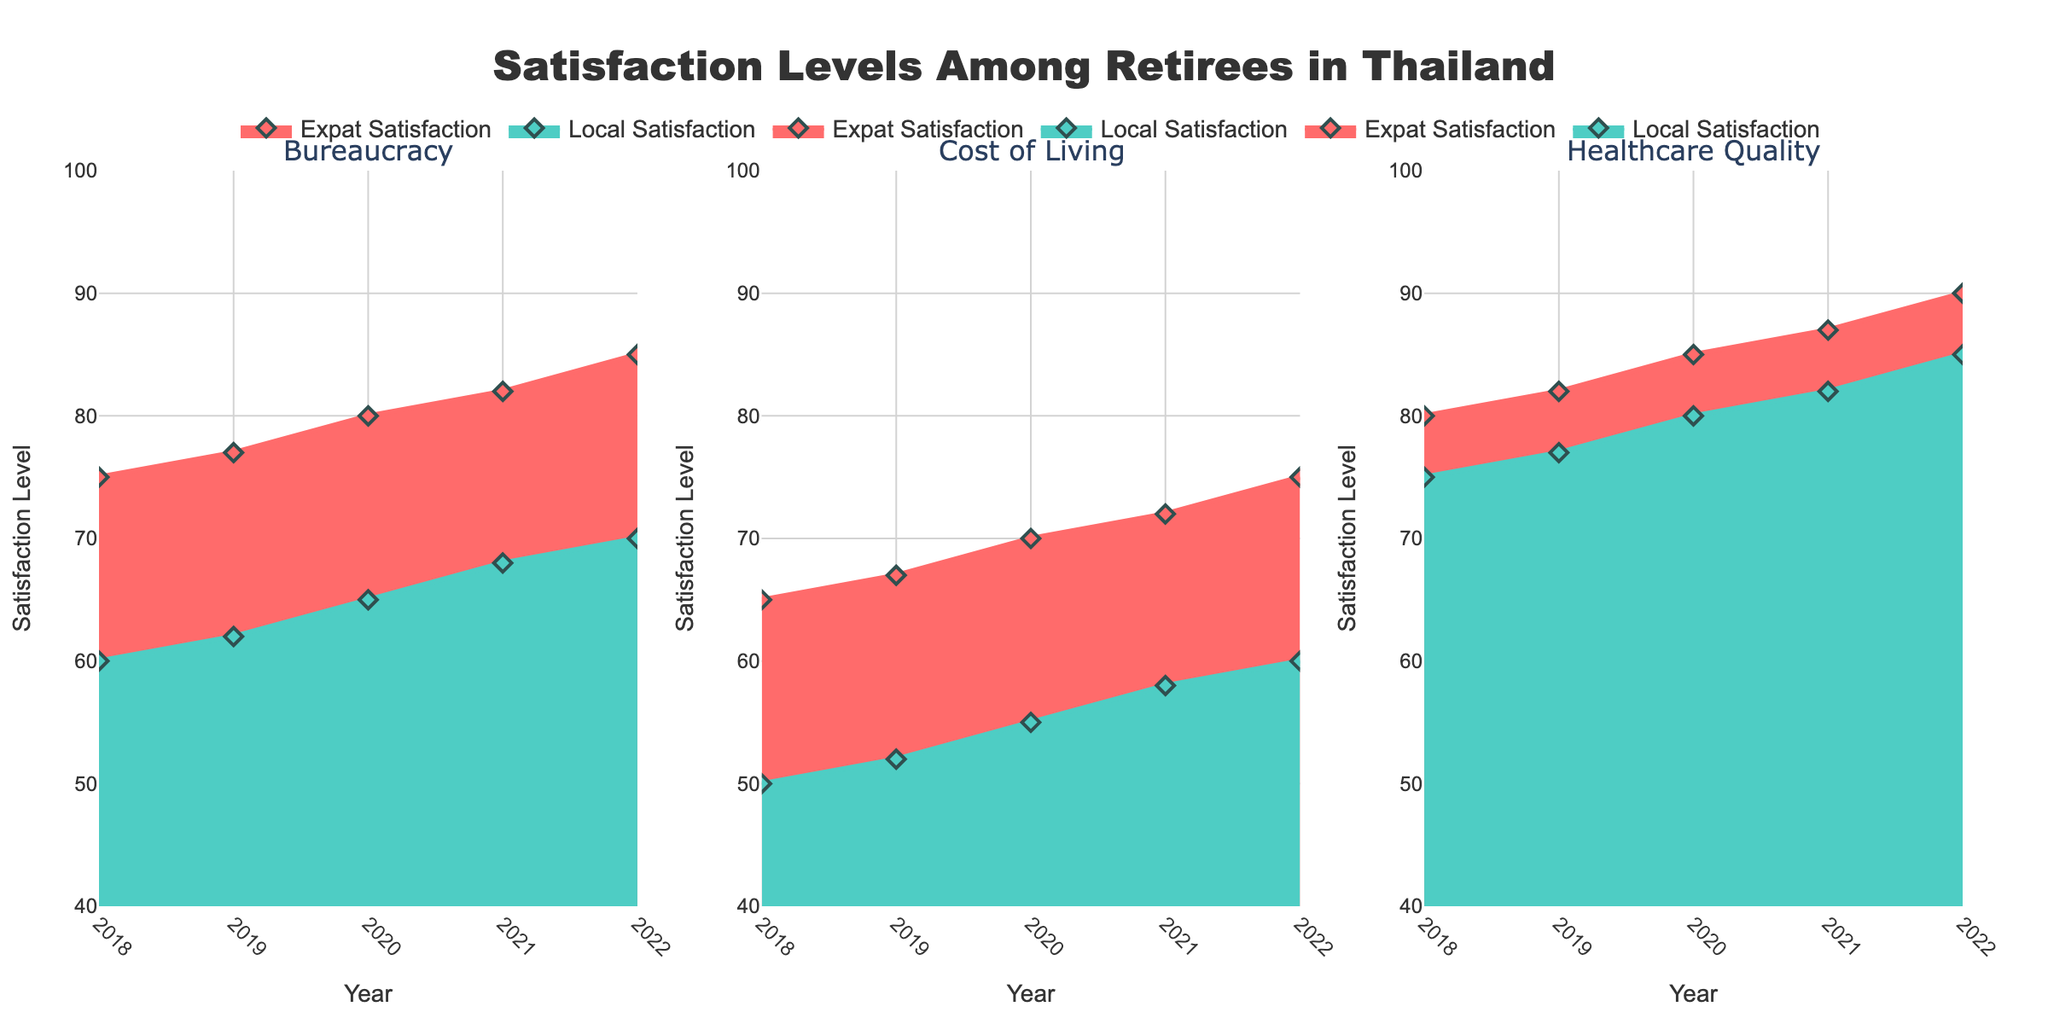What is the title of the figure? The title is located at the top of the figure and reads "Satisfaction Levels Among Retirees in Thailand".
Answer: Satisfaction Levels Among Retirees in Thailand Which factor consistently shows the highest satisfaction levels for both Expat and Local retirees? By examining the three subplots, "Healthcare Quality" consistently has the highest satisfaction levels for both categories.
Answer: Healthcare Quality What was the satisfaction level of Expats with "Bureaucracy" in 2020? Locate the "Bureaucracy" subplot, find the data point for the Expat category in 2020.
Answer: 80 How did the satisfaction levels of Locals with "Cost of Living" change from 2019 to 2021? In the "Cost of Living" subplot, find the values for Locals in 2019 (52) and 2021 (58). Subtract the 2019 value from the 2021 value (58 - 52).
Answer: Increased by 6 points In 2022, which group had a higher satisfaction level regarding "Healthcare Quality"? Compare the 2022 data points in the "Healthcare Quality" subplot for Expats (90) and Locals (85).
Answer: Expats What is the average satisfaction level of Expats in "Cost of Living" from 2018 to 2022? Locate all the data points for Expats in "Cost of Living" subplot (2018: 65, 2019: 67, 2020: 70, 2021: 72, 2022: 75). Sum these values and divide by the number of points (65 + 67 + 70 + 72 + 75) / 5.
Answer: 69.8 Did the satisfaction level with "Bureaucracy" for Locals ever surpass that for Expats during the period shown? Analyze the "Bureaucracy" subplot for overlap where Local satisfaction surpasses Expat satisfaction, which it does not.
Answer: No Which year saw the largest increase in satisfaction for Expats in "Healthcare Quality"? Examine the "Healthcare Quality" subplot for Expats and determine year-to-year changes: 2018 to 2019 (80 to 82: +2), 2019 to 2020 (82 to 85: +3), 2020 to 2021 (85 to 87: +2), 2021 to 2022 (87 to 90: +3). The largest increases were in 2020 and 2022.
Answer: 2020 and 2022 What trend can be observed for Local satisfaction with "Bureaucracy" over the years? Observe the "Bureaucracy" subplot and see a gradual increase in satisfaction levels from 60 in 2018 to 70 in 2022.
Answer: Gradually increasing In terms of "Healthcare Quality", how much higher was Expat satisfaction compared to Local satisfaction in 2022? In the "Healthcare Quality" subplot for 2022, subtract Local satisfaction (85) from Expat satisfaction (90).
Answer: 5 points 